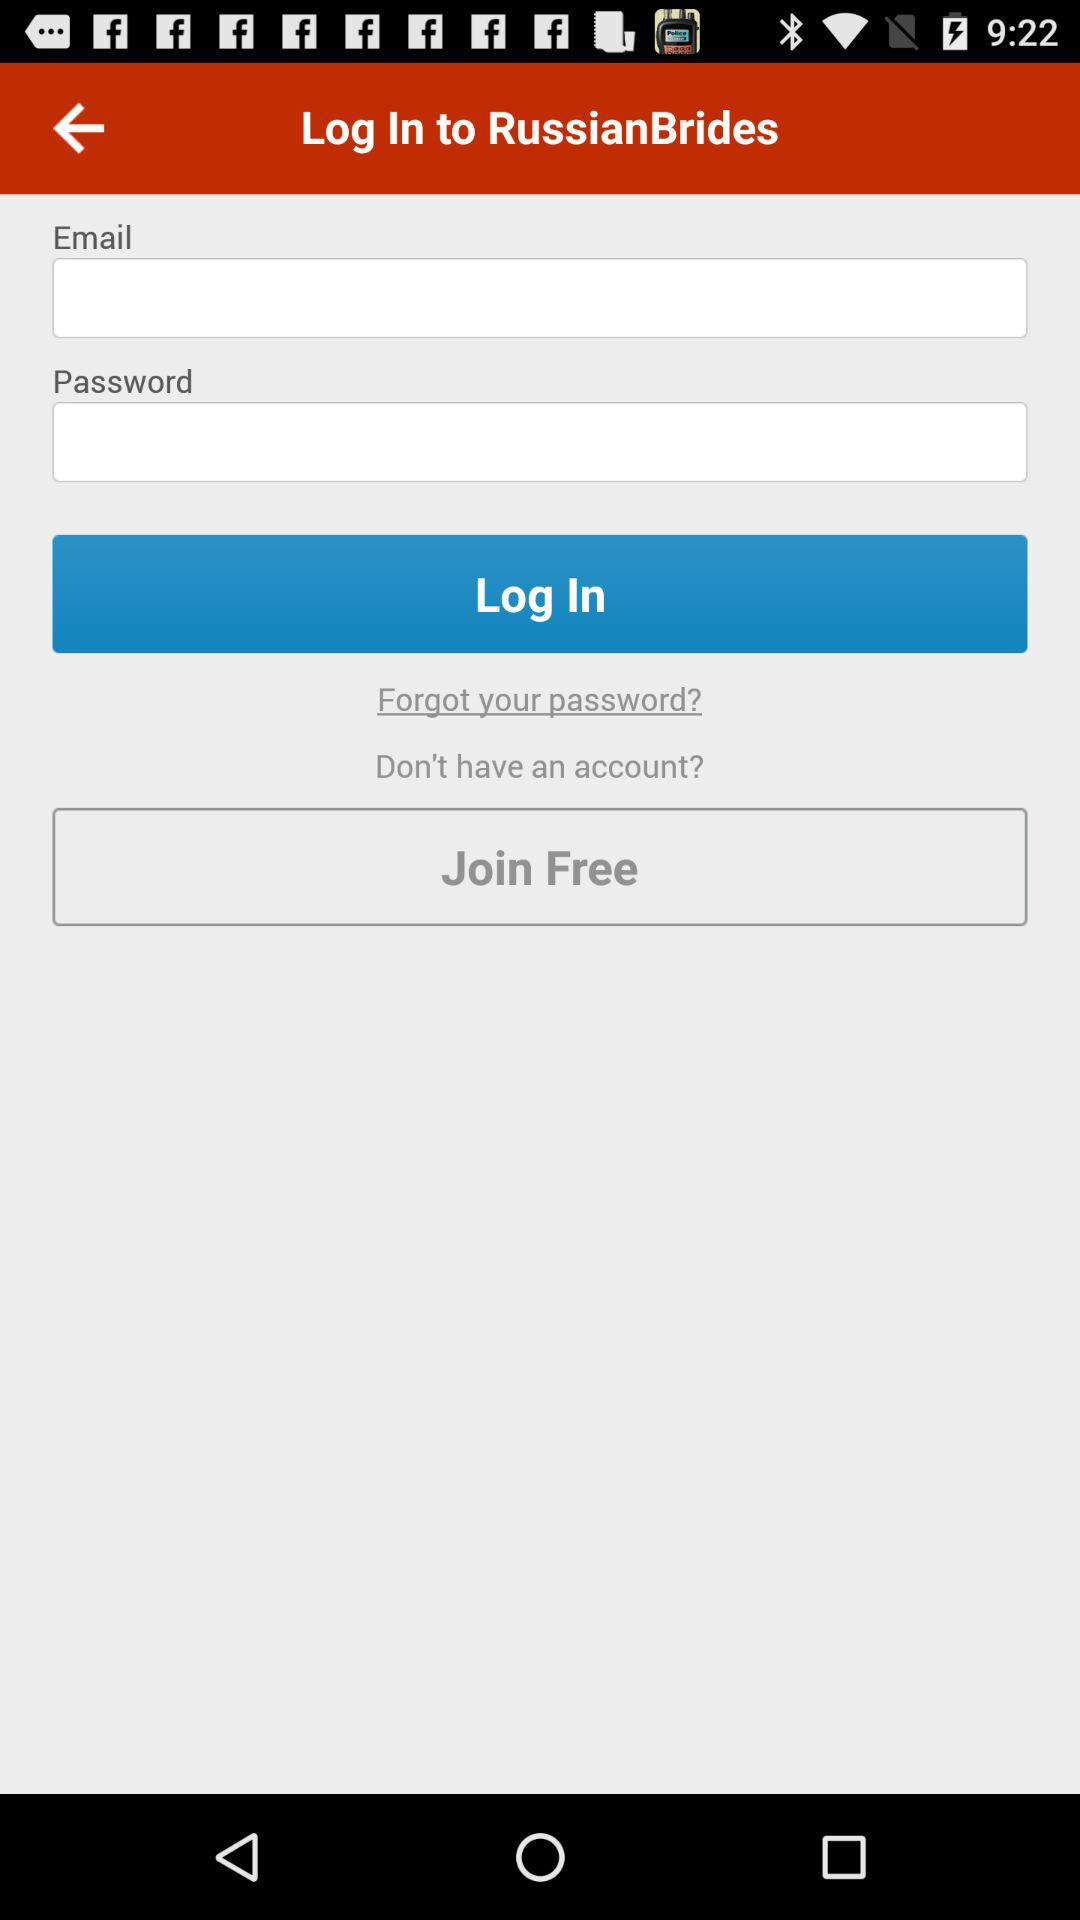What is the name of the application? The name of the application is "RussianBrides". 